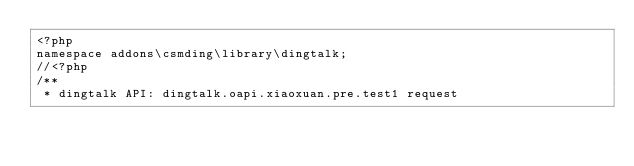<code> <loc_0><loc_0><loc_500><loc_500><_PHP_><?php 
namespace addons\csmding\library\dingtalk;
//<?php
/**
 * dingtalk API: dingtalk.oapi.xiaoxuan.pre.test1 request</code> 